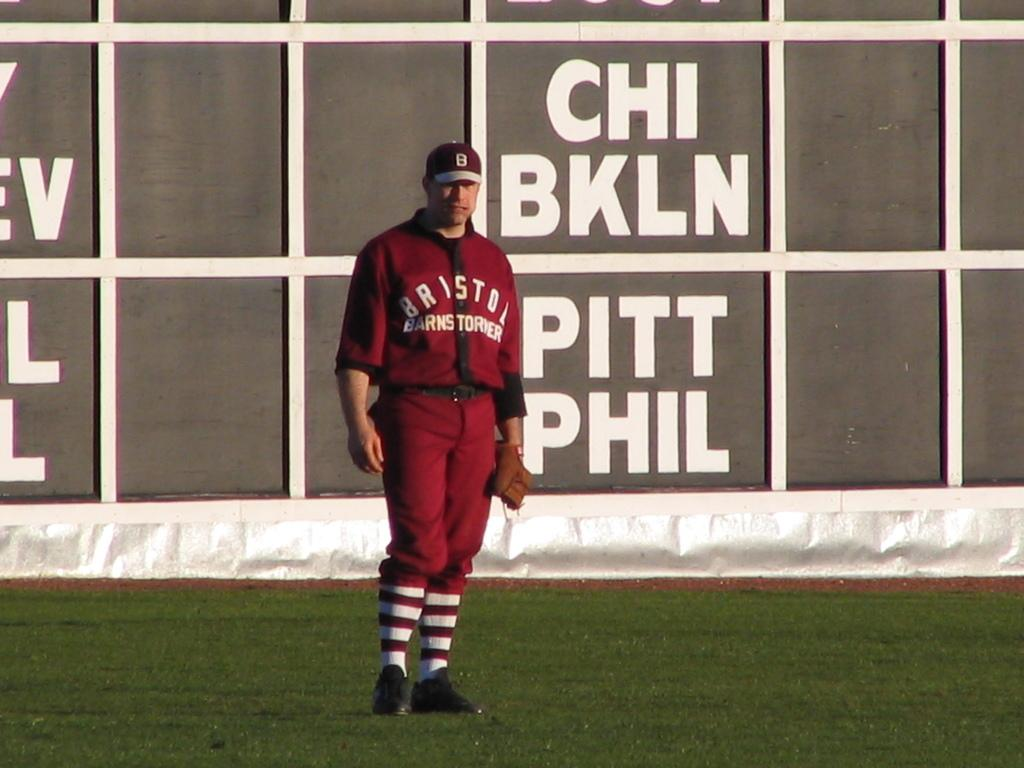<image>
Relay a brief, clear account of the picture shown. A baseball player holding a mitt and has on a red and white outfit. 